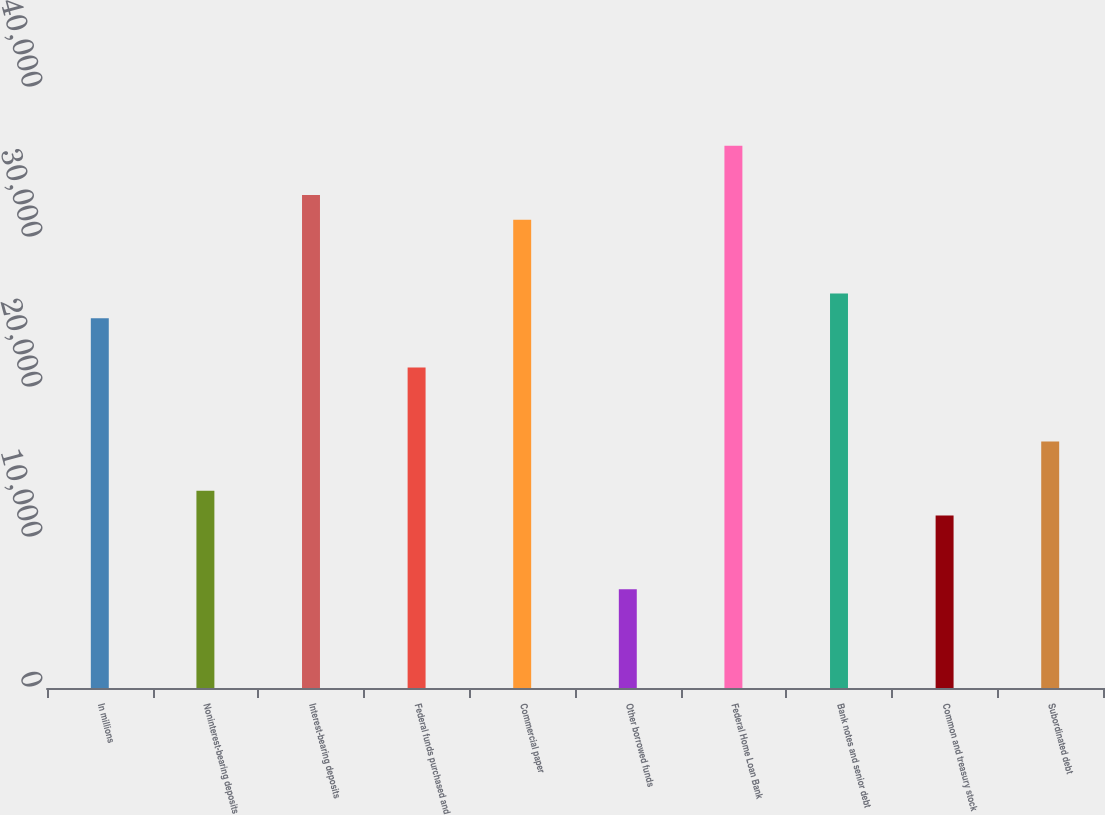<chart> <loc_0><loc_0><loc_500><loc_500><bar_chart><fcel>In millions<fcel>Noninterest-bearing deposits<fcel>Interest-bearing deposits<fcel>Federal funds purchased and<fcel>Commercial paper<fcel>Other borrowed funds<fcel>Federal Home Loan Bank<fcel>Bank notes and senior debt<fcel>Common and treasury stock<fcel>Subordinated debt<nl><fcel>24651<fcel>13148.6<fcel>32867<fcel>21364.6<fcel>31223.8<fcel>6575.8<fcel>36153.4<fcel>26294.2<fcel>11505.4<fcel>16435<nl></chart> 